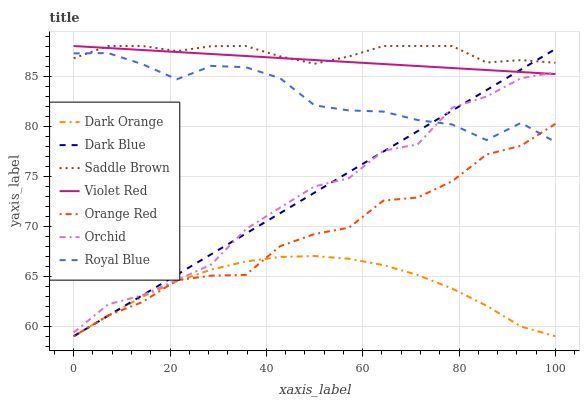Does Dark Orange have the minimum area under the curve?
Answer yes or no. Yes. Does Saddle Brown have the maximum area under the curve?
Answer yes or no. Yes. Does Violet Red have the minimum area under the curve?
Answer yes or no. No. Does Violet Red have the maximum area under the curve?
Answer yes or no. No. Is Violet Red the smoothest?
Answer yes or no. Yes. Is Royal Blue the roughest?
Answer yes or no. Yes. Is Royal Blue the smoothest?
Answer yes or no. No. Is Violet Red the roughest?
Answer yes or no. No. Does Dark Orange have the lowest value?
Answer yes or no. Yes. Does Violet Red have the lowest value?
Answer yes or no. No. Does Saddle Brown have the highest value?
Answer yes or no. Yes. Does Royal Blue have the highest value?
Answer yes or no. No. Is Orange Red less than Violet Red?
Answer yes or no. Yes. Is Royal Blue greater than Dark Orange?
Answer yes or no. Yes. Does Orchid intersect Dark Blue?
Answer yes or no. Yes. Is Orchid less than Dark Blue?
Answer yes or no. No. Is Orchid greater than Dark Blue?
Answer yes or no. No. Does Orange Red intersect Violet Red?
Answer yes or no. No. 